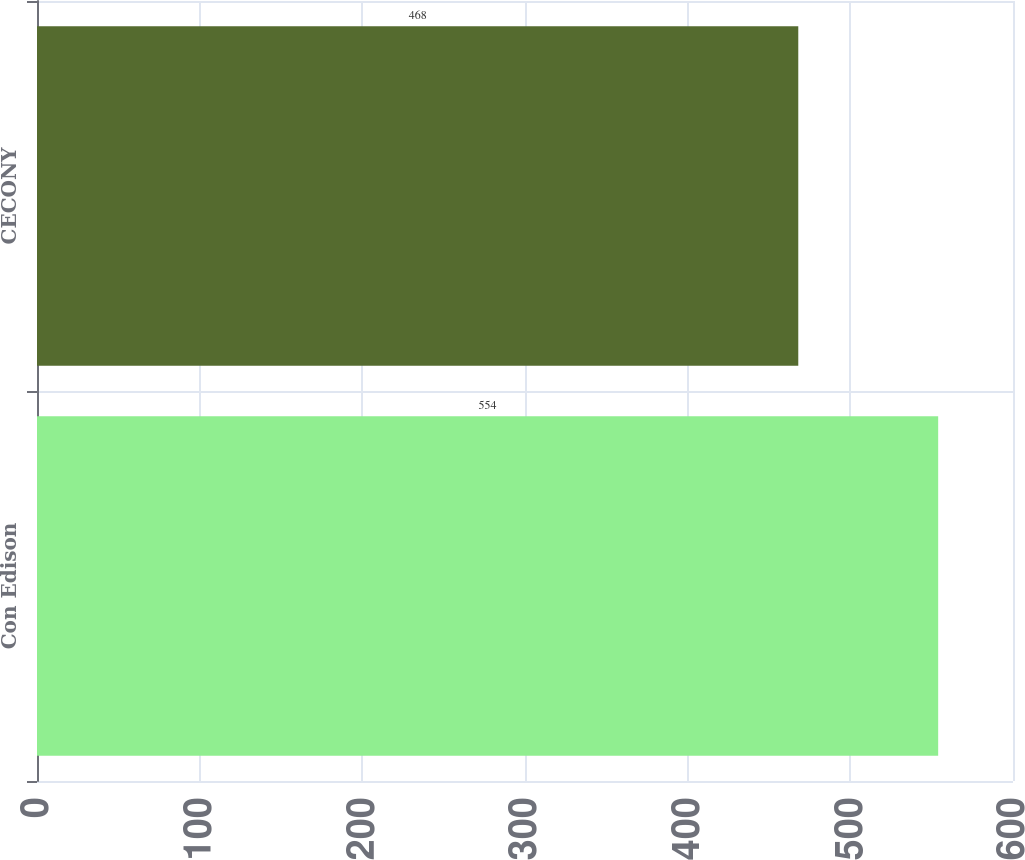Convert chart to OTSL. <chart><loc_0><loc_0><loc_500><loc_500><bar_chart><fcel>Con Edison<fcel>CECONY<nl><fcel>554<fcel>468<nl></chart> 